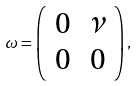<formula> <loc_0><loc_0><loc_500><loc_500>\omega = \left ( \begin{array} { r r } 0 & \nu \\ 0 & 0 \end{array} \right ) ,</formula> 